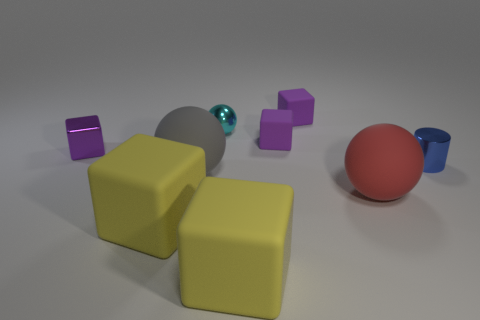How many big things have the same color as the small cylinder?
Offer a very short reply. 0. There is a matte ball to the left of the tiny matte object that is in front of the ball behind the cylinder; how big is it?
Give a very brief answer. Large. What number of metallic things are purple cubes or big balls?
Make the answer very short. 1. There is a small blue object; is it the same shape as the purple matte object that is behind the tiny cyan metallic thing?
Provide a succinct answer. No. Is the number of large gray things right of the big red object greater than the number of small spheres right of the small cyan sphere?
Ensure brevity in your answer.  No. Is there any other thing that has the same color as the metallic cylinder?
Offer a very short reply. No. Are there any purple cubes that are on the right side of the big yellow rubber block behind the big cube right of the gray matte sphere?
Your answer should be very brief. Yes. Is the shape of the tiny object that is right of the big red rubber thing the same as  the small cyan shiny thing?
Make the answer very short. No. Is the number of small cyan metallic things left of the cyan object less than the number of big gray spheres that are behind the metallic block?
Make the answer very short. No. What is the material of the tiny sphere?
Give a very brief answer. Metal. 